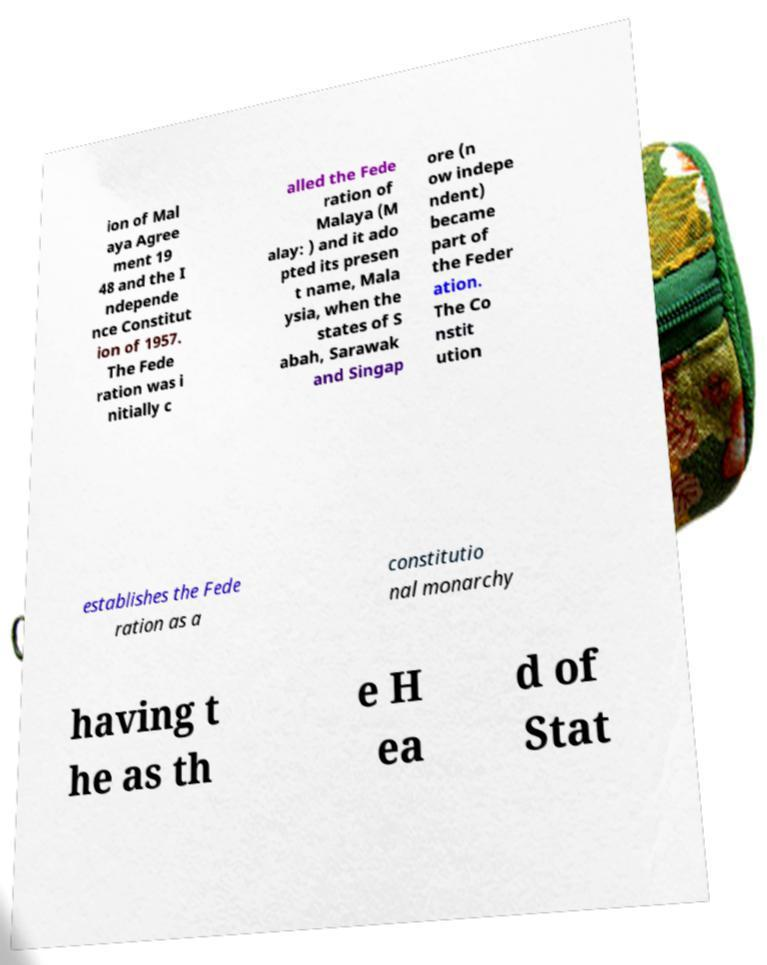What messages or text are displayed in this image? I need them in a readable, typed format. ion of Mal aya Agree ment 19 48 and the I ndepende nce Constitut ion of 1957. The Fede ration was i nitially c alled the Fede ration of Malaya (M alay: ) and it ado pted its presen t name, Mala ysia, when the states of S abah, Sarawak and Singap ore (n ow indepe ndent) became part of the Feder ation. The Co nstit ution establishes the Fede ration as a constitutio nal monarchy having t he as th e H ea d of Stat 